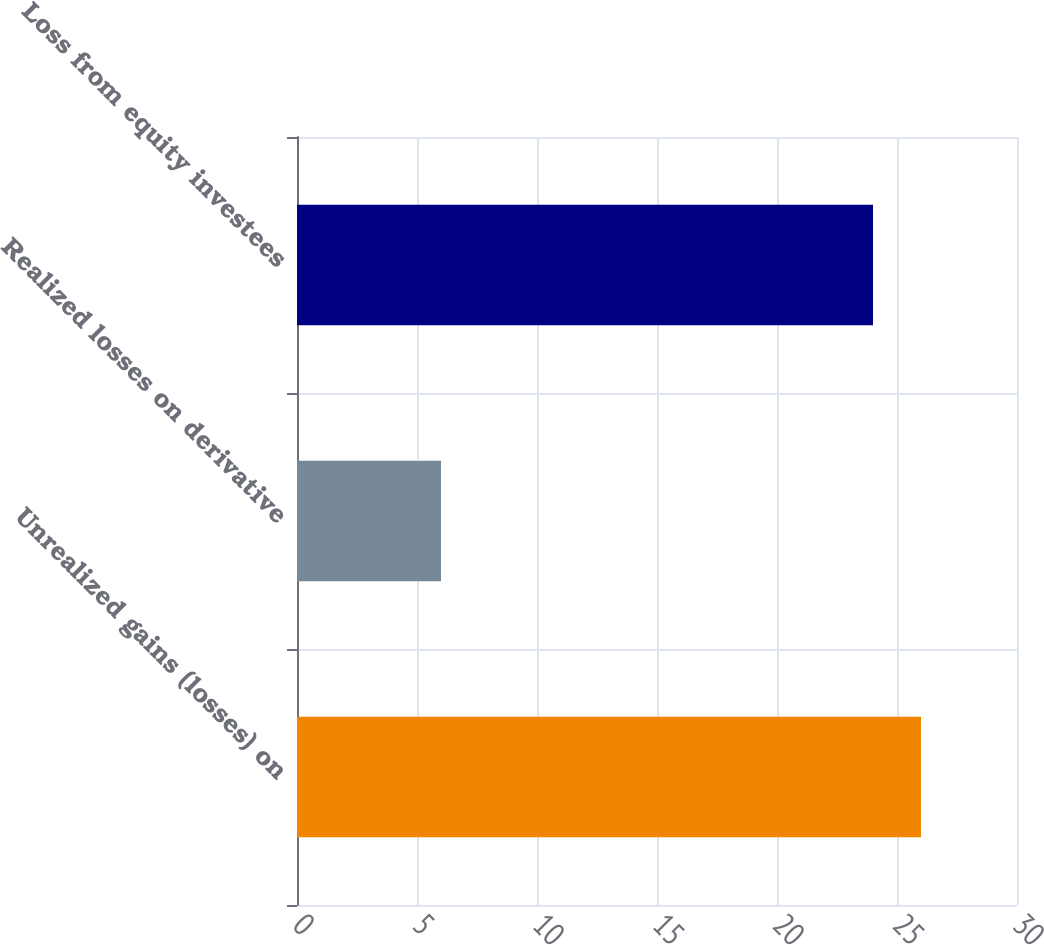Convert chart. <chart><loc_0><loc_0><loc_500><loc_500><bar_chart><fcel>Unrealized gains (losses) on<fcel>Realized losses on derivative<fcel>Loss from equity investees<nl><fcel>26<fcel>6<fcel>24<nl></chart> 